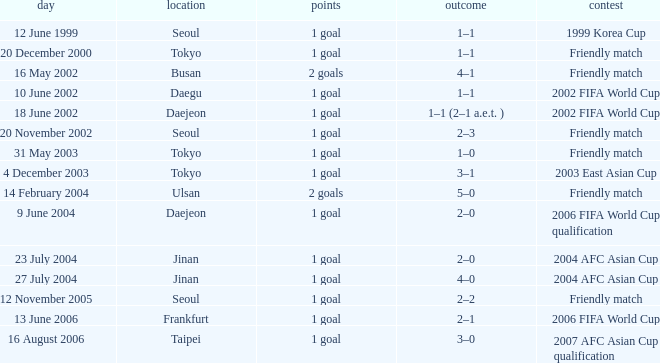What is the venue for the event on 12 November 2005? Seoul. 